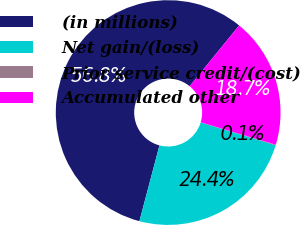Convert chart. <chart><loc_0><loc_0><loc_500><loc_500><pie_chart><fcel>(in millions)<fcel>Net gain/(loss)<fcel>Prior service credit/(cost)<fcel>Accumulated other<nl><fcel>56.77%<fcel>24.41%<fcel>0.08%<fcel>18.74%<nl></chart> 